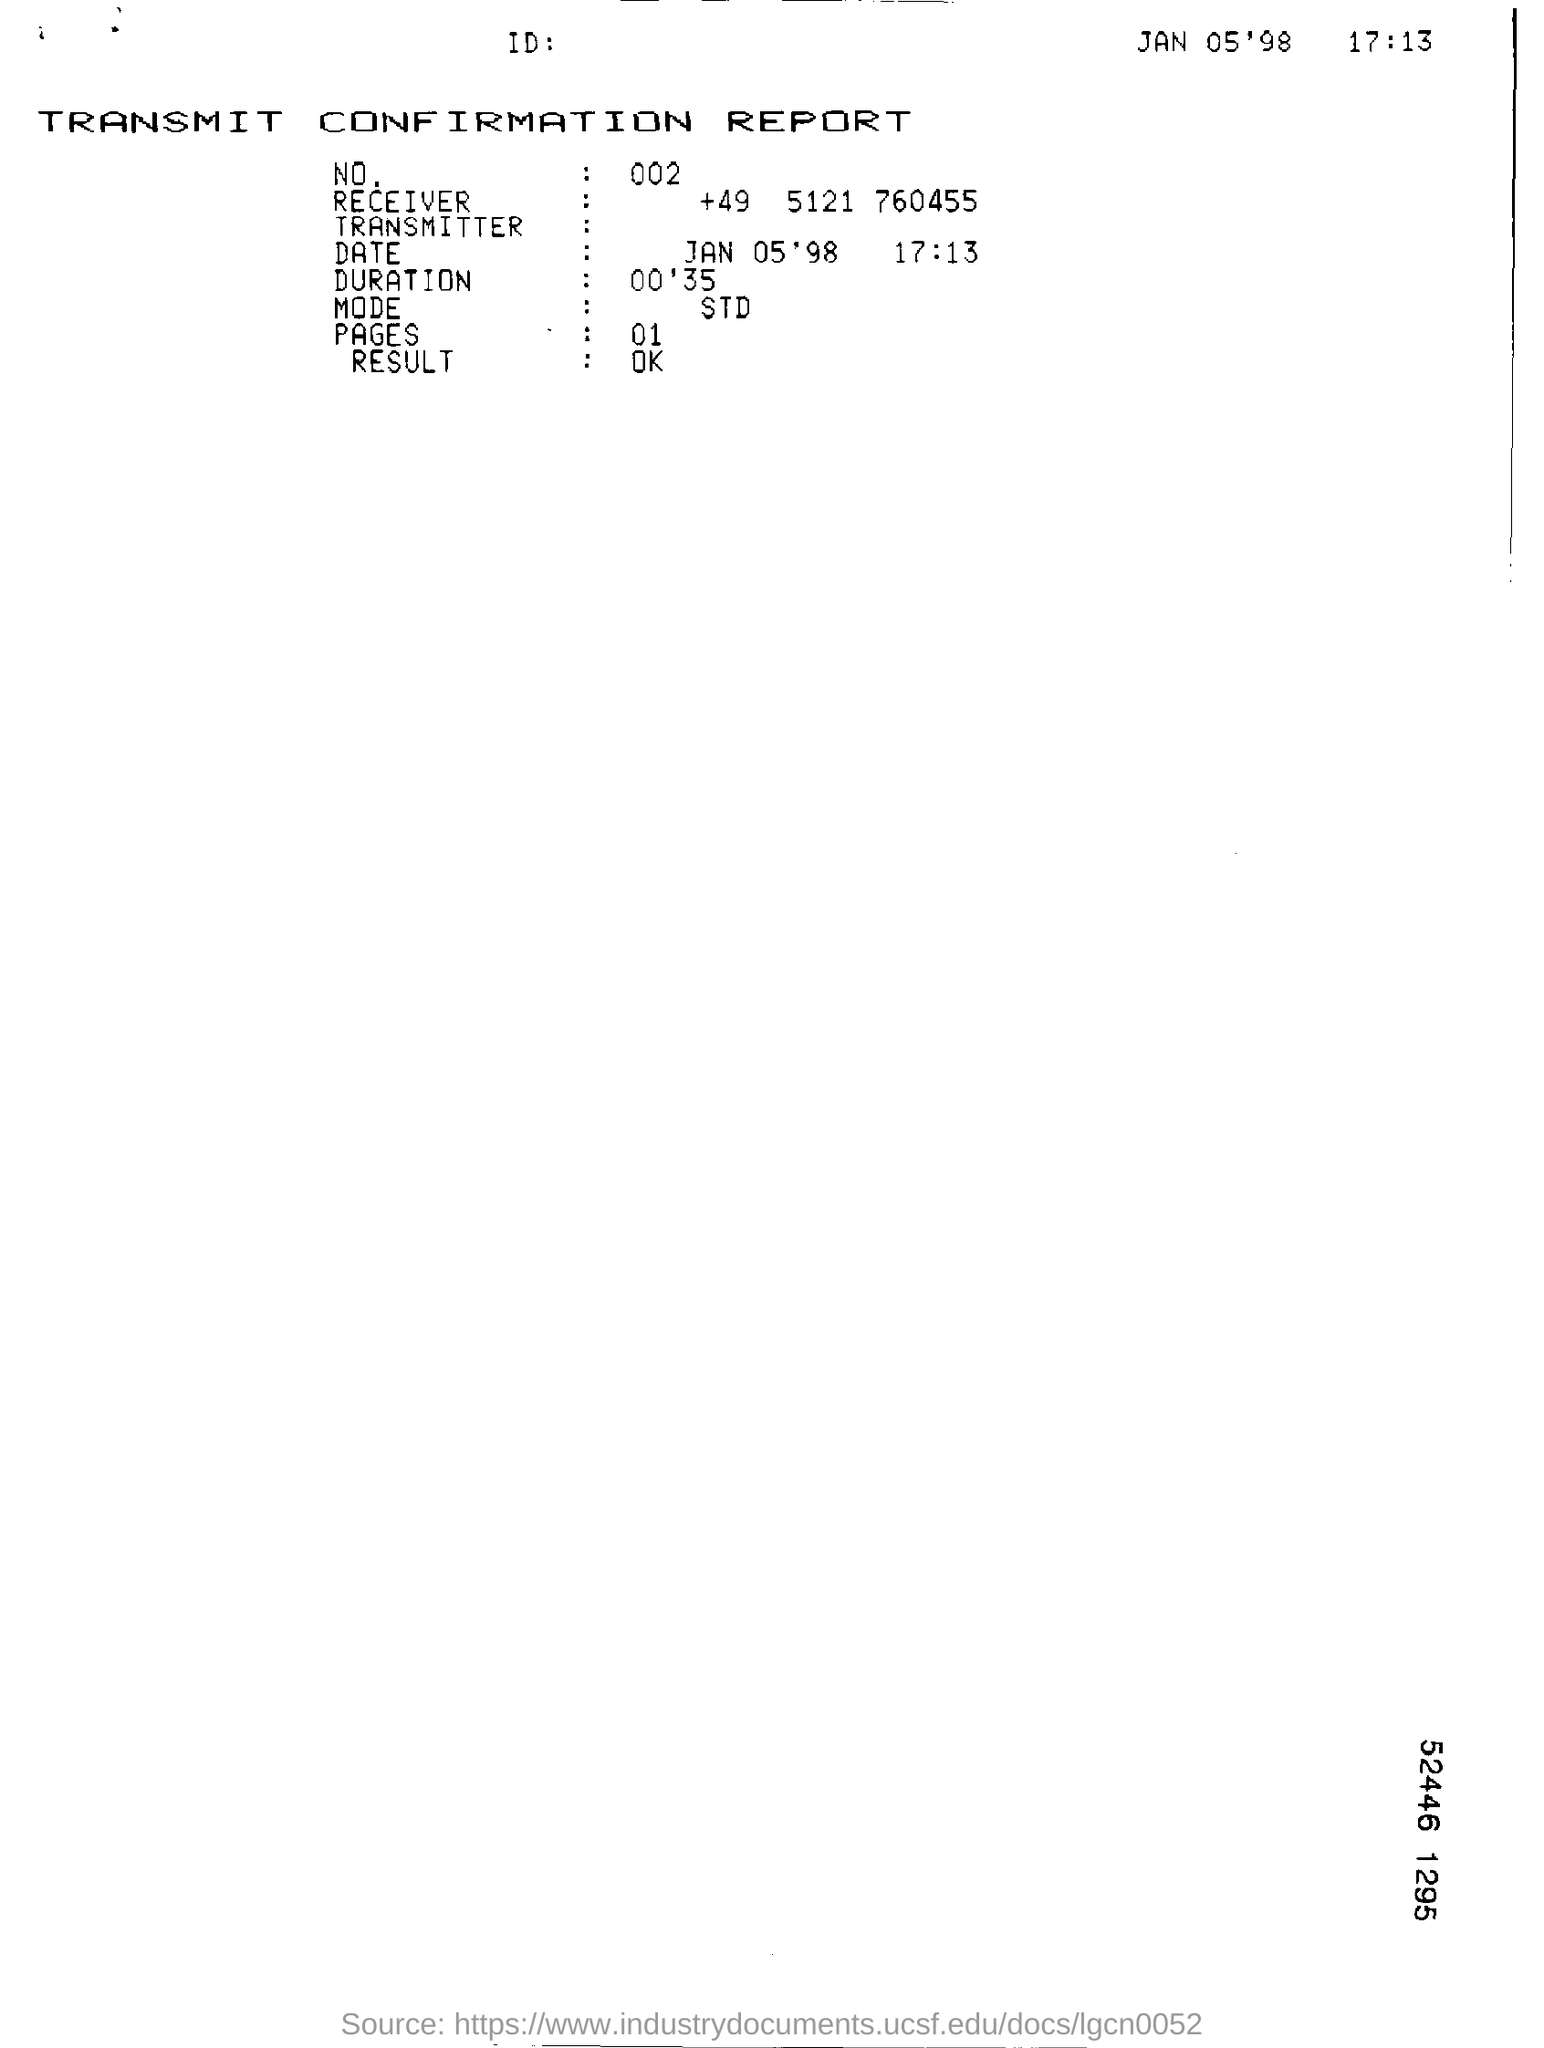Mention a couple of crucial points in this snapshot. The duration listed in the transmit confirmation report is 00'35. The date and time mentioned in the transmit confirmation report are January 5th, 1998 at 5:13 PM. The number mentioned in the transmit confirmation report is 002. 